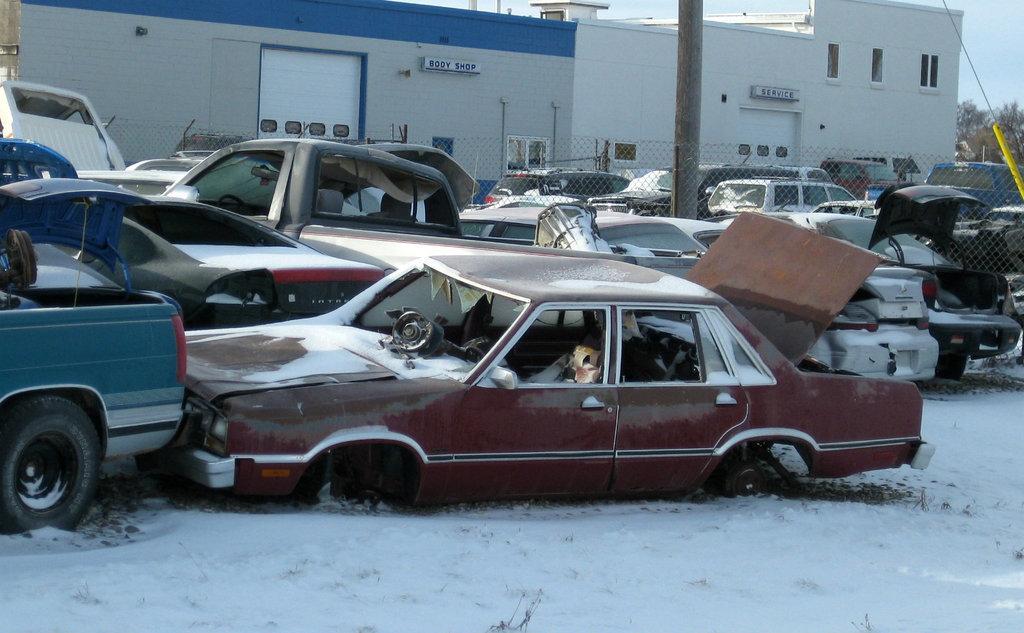Can you describe this image briefly? As we can see in the image there are cars, snow, fence, buildings, windows, trees and sky. 